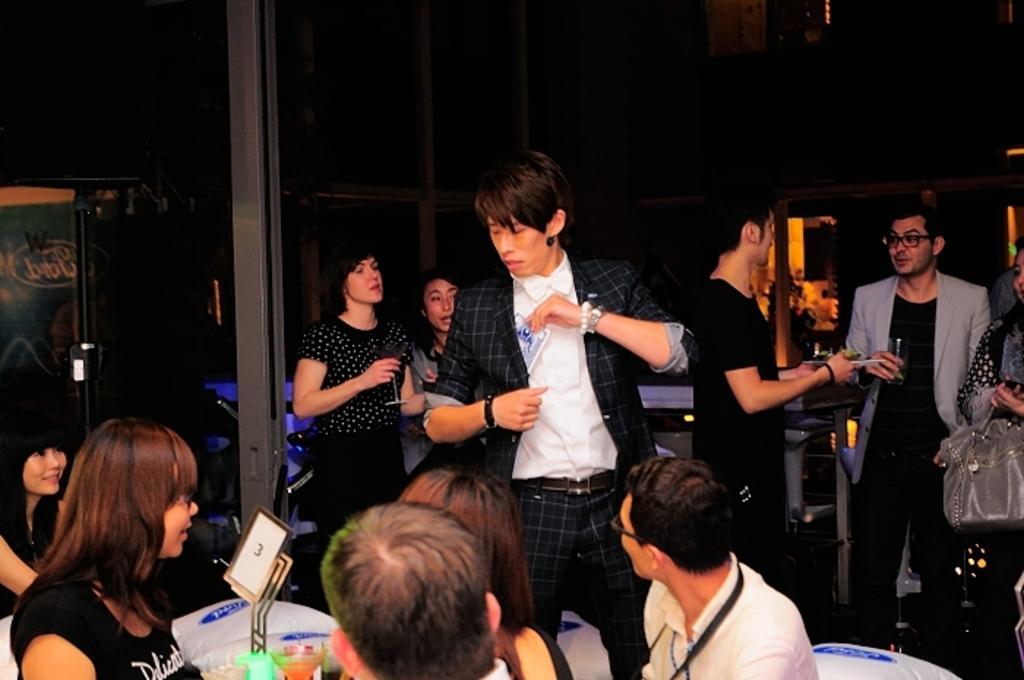Could you give a brief overview of what you see in this image? In the picture I can see a few persons and looks like they are having a drink. I can see a man in the middle of the picture. He is wearing a suit and he is picking something from his suit pocket. There are two men on the right side and they are having a conversation. I can see a woman on the left side and she is holding a wine glass in her right hand. I can see a few people at the bottom of the image. 